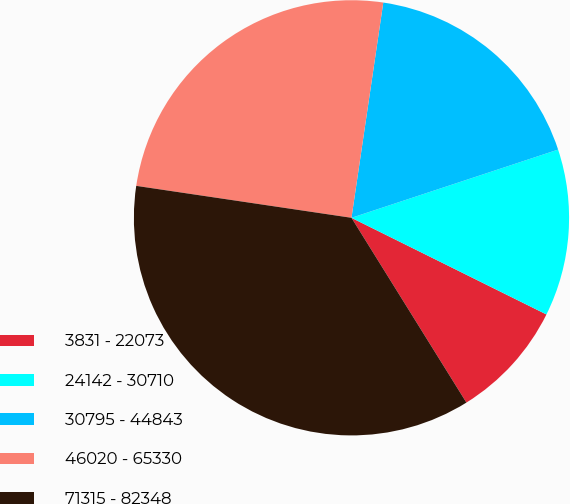Convert chart to OTSL. <chart><loc_0><loc_0><loc_500><loc_500><pie_chart><fcel>3831 - 22073<fcel>24142 - 30710<fcel>30795 - 44843<fcel>46020 - 65330<fcel>71315 - 82348<nl><fcel>8.82%<fcel>12.4%<fcel>17.59%<fcel>24.99%<fcel>36.2%<nl></chart> 